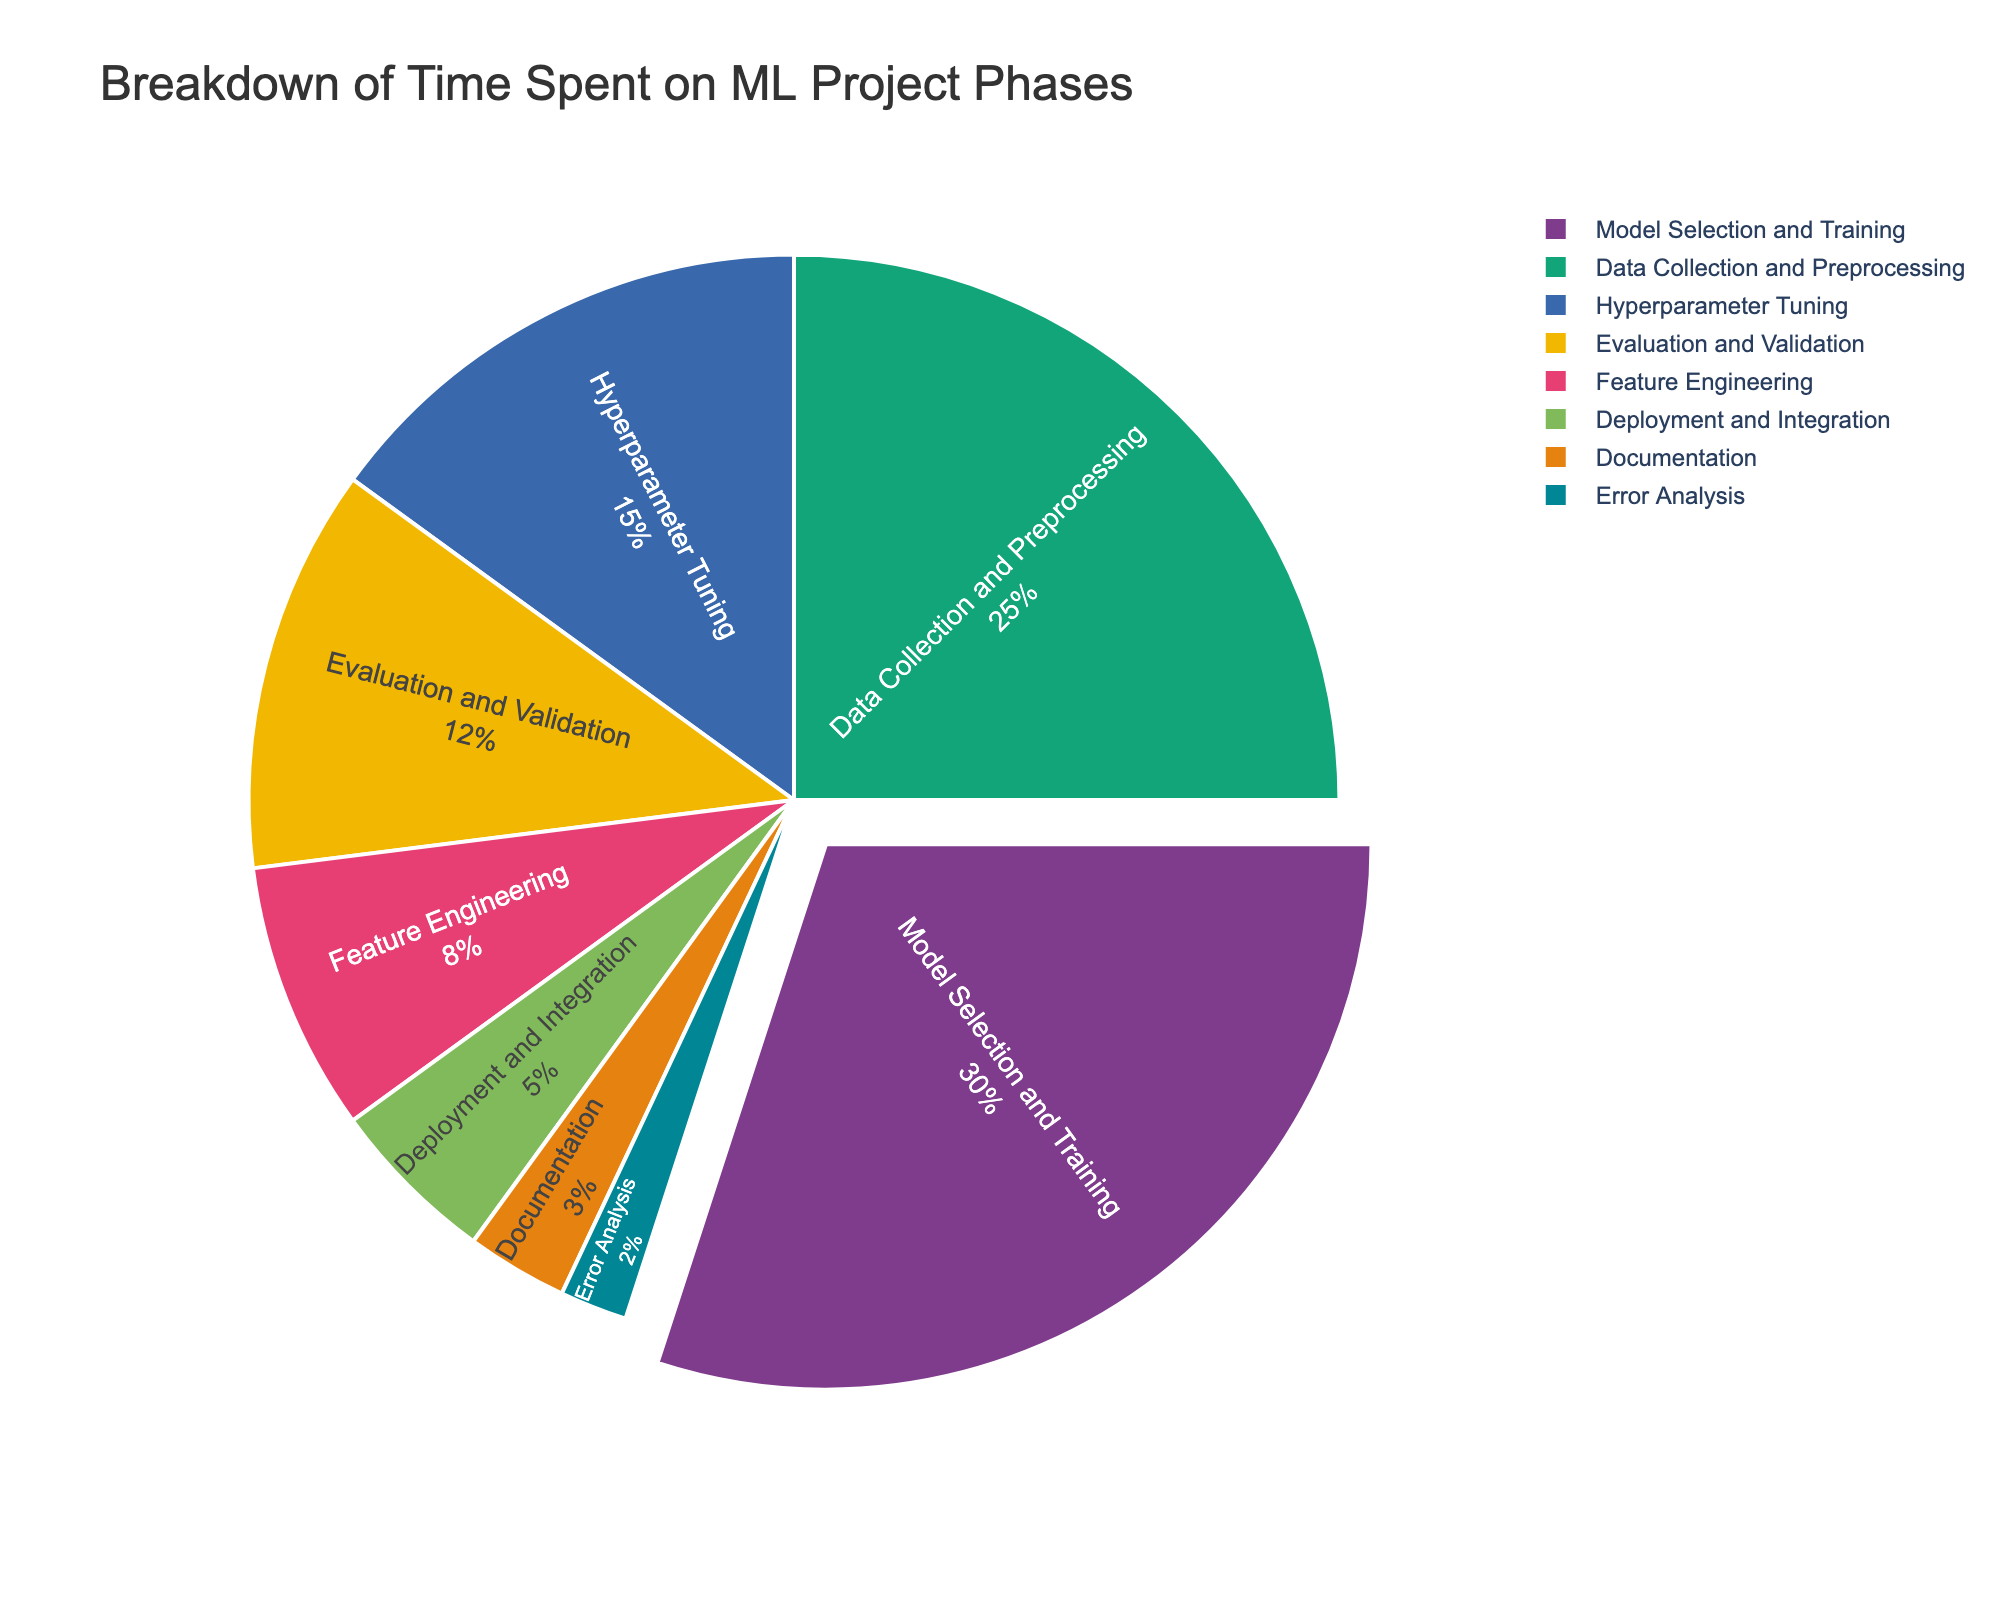What's the total percentage of time spent on Deployment and Integration and Documentation phases? Sum the percentages of Deployment and Integration (5%) and Documentation (3%). 5% + 3% = 8%
Answer: 8% Which phase takes up the most time in the machine learning project lifecycle? Identify the phase with the highest percentage from the pie chart; Model Selection and Training has the highest value of 30%.
Answer: Model Selection and Training Which phase(s) use the least amount of time, and what's their percentage? Identify the phase with the smallest percentage; Error Analysis is at 2%.
Answer: Error Analysis, 2% How does the time spent on Feature Engineering compare to the time spent on Evaluation and Validation? Compare the percentages of the two phases from the chart; Feature Engineering is 8%, and Evaluation and Validation is 12%.
Answer: Feature Engineering is 4% less than Evaluation and Validation What's the combined percentage of time spent on Model Selection and Training, and Hyperparameter Tuning? Sum the percentages of Model Selection and Training (30%) and Hyperparameter Tuning (15%). 30% + 15% = 45%
Answer: 45% Which phase takes more time, Data Collection and Preprocessing or Feature Engineering? Compare the percentages of Data Collection and Preprocessing (25%) to Feature Engineering (8%).
Answer: Data Collection and Preprocessing Visualize the visual difference between Data Collection and Preprocessing and Hyperparameter Tuning, in terms of percentage Data Collection and Preprocessing takes 25% while Hyperparameter Tuning takes 15%; visually, a larger slice represents Data Collection and Preprocessing compared to Hyperparameter Tuning
Answer: Data Collection and Preprocessing is visibly larger If you were to reduce the time spent on Model Selection and Training by 5%, what would its new percentage be? Subtract 5% from Model Selection and Training’s original percentage (30% - 5% = 25%).
Answer: 25% Identify the phase or phases that take less than or equal to 5% of the time Based on the chart, Deployment and Integration takes 5% and both Documentation and Error Analysis take less than 5%
Answer: Deployment and Integration, Documentation, Error Analysis 